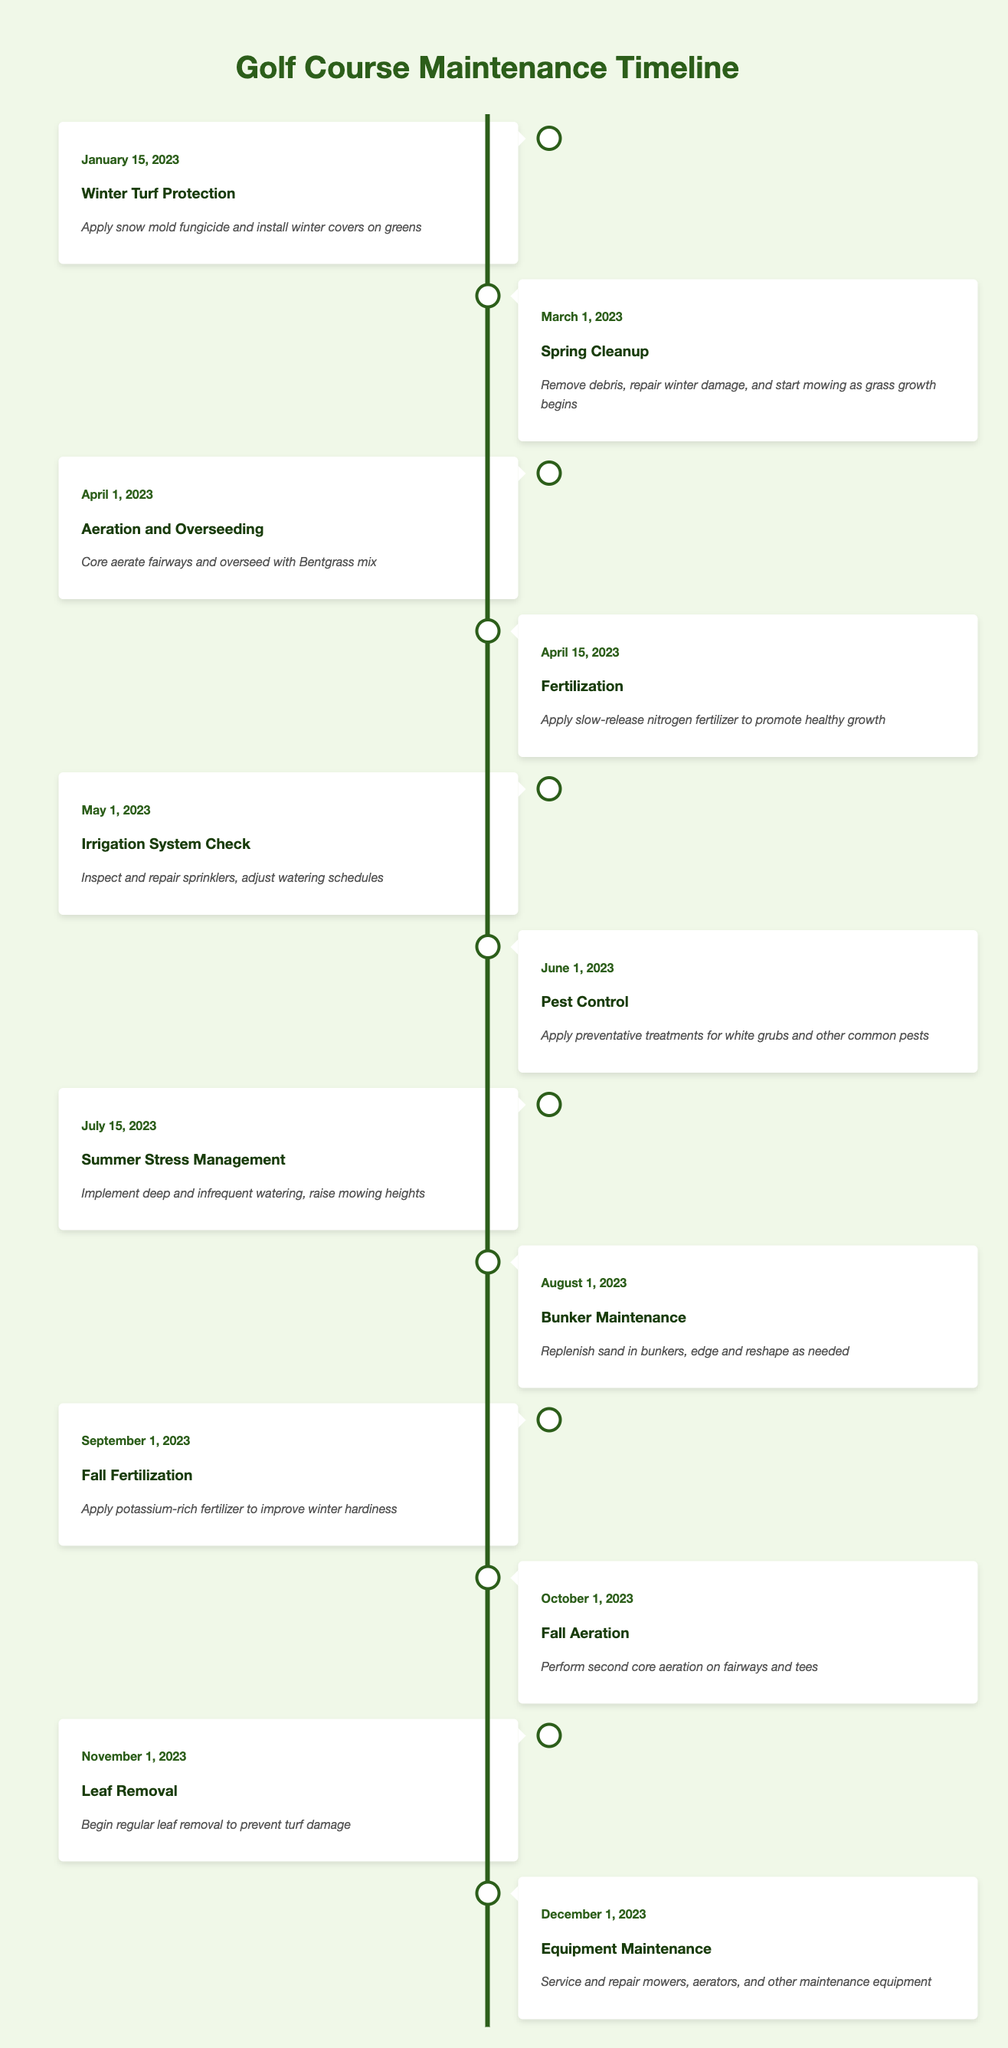What maintenance task is scheduled for January 15, 2023? According to the timeline, the event scheduled for January 15, 2023, is "Winter Turf Protection." It involves applying snow mold fungicide and installing winter covers on greens.
Answer: Winter Turf Protection How many maintenance events are scheduled in the month of April? There are two events scheduled in April: "Aeration and Overseeding" on April 1, and "Fertilization" on April 15.
Answer: 2 What is the last maintenance task of the year? The last task of the year is "Equipment Maintenance" scheduled for December 1, 2023. This task involves servicing and repairing mowers, aerators, and other maintenance equipment.
Answer: Equipment Maintenance Is there a maintenance task scheduled for July 1, 2023? The timeline does not list an event on July 1, 2023. The nearest scheduled event is "Summer Stress Management" on July 15.
Answer: No Which event occurs immediately after the "Pest Control" task? The event that occurs immediately after "Pest Control," which is scheduled on June 1, 2023, is "Summer Stress Management" on July 15, 2023.
Answer: Summer Stress Management What is the frequency of aeration events throughout the year? There are two aeration events in the year: "Aeration and Overseeding" on April 1 and "Fall Aeration" on October 1. Therefore, the frequency of aeration events is twice a year.
Answer: Twice What maintenance tasks are scheduled between June and August? The tasks scheduled between June and August are: "Pest Control" on June 1, "Summer Stress Management" on July 15, and "Bunker Maintenance" on August 1.
Answer: Pest Control, Summer Stress Management, Bunker Maintenance What is the average time duration between the Spring Cleanup and Fertilization events? The duration between the "Spring Cleanup" on March 1 and "Fertilization" on April 15 is 15 days (March has 31 days, so from March 1 to March 31 is 30 days, plus 15 in April). There are 2 weeks and 1 day, resulting in roughly 2 weeks on average between these events.
Answer: 15 days How does the frequency of fertilization compare to aeration tasks? Fertilization occurs once in spring on April 15 and once in fall on September 1, totaling two fertilization events. Since there are also two aeration events scheduled in the year, their frequencies are equal, both occurring twice a year.
Answer: Equal frequency 